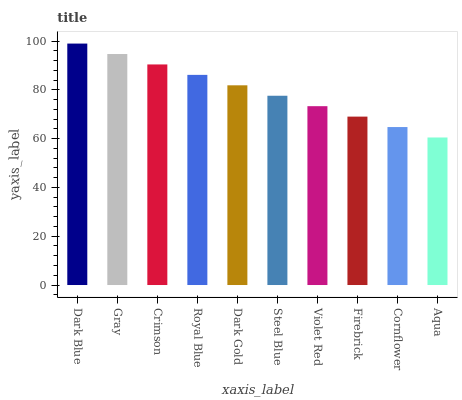Is Gray the minimum?
Answer yes or no. No. Is Gray the maximum?
Answer yes or no. No. Is Dark Blue greater than Gray?
Answer yes or no. Yes. Is Gray less than Dark Blue?
Answer yes or no. Yes. Is Gray greater than Dark Blue?
Answer yes or no. No. Is Dark Blue less than Gray?
Answer yes or no. No. Is Dark Gold the high median?
Answer yes or no. Yes. Is Steel Blue the low median?
Answer yes or no. Yes. Is Firebrick the high median?
Answer yes or no. No. Is Dark Blue the low median?
Answer yes or no. No. 